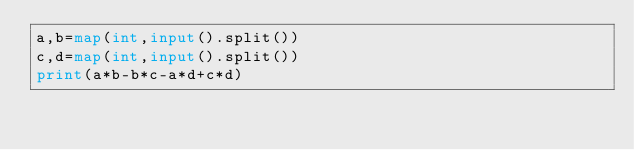<code> <loc_0><loc_0><loc_500><loc_500><_Python_>a,b=map(int,input().split())
c,d=map(int,input().split())
print(a*b-b*c-a*d+c*d)</code> 